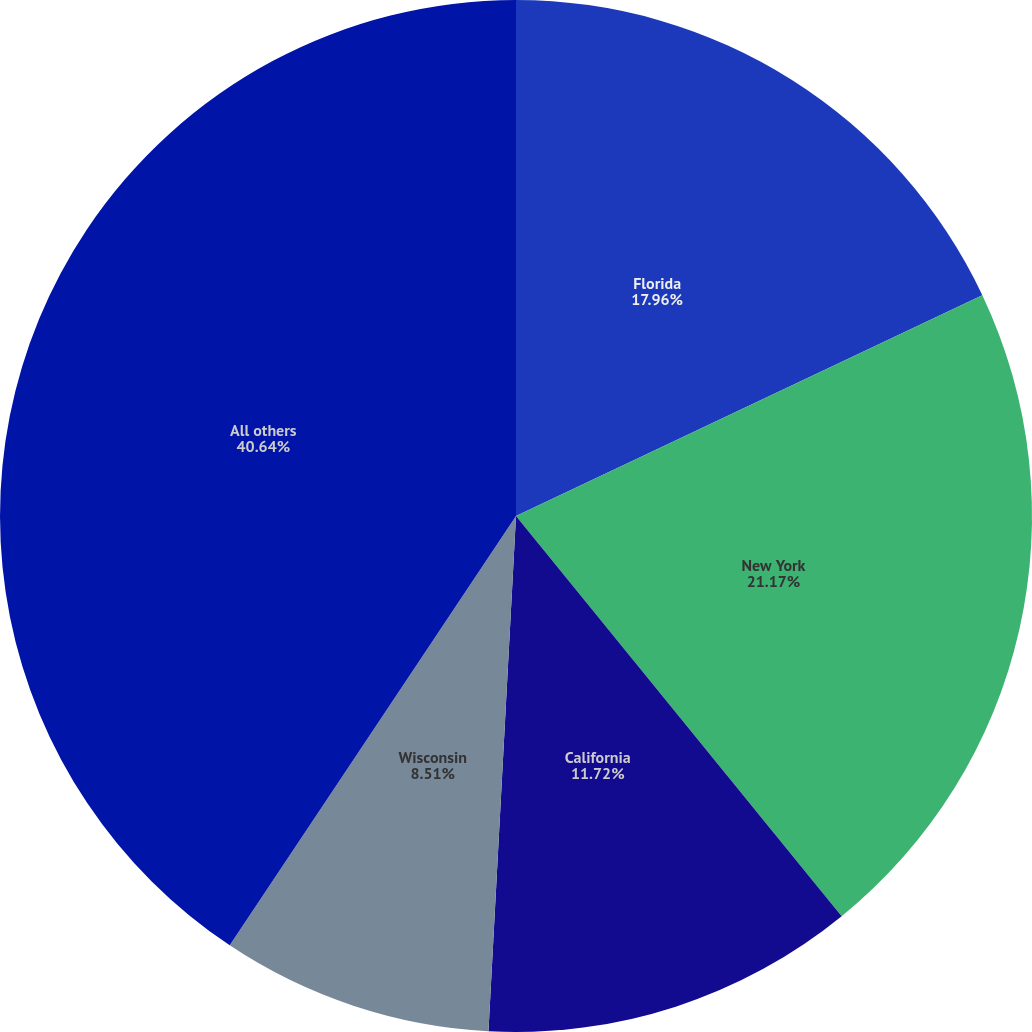Convert chart to OTSL. <chart><loc_0><loc_0><loc_500><loc_500><pie_chart><fcel>Florida<fcel>New York<fcel>California<fcel>Wisconsin<fcel>All others<nl><fcel>17.96%<fcel>21.17%<fcel>11.72%<fcel>8.51%<fcel>40.64%<nl></chart> 